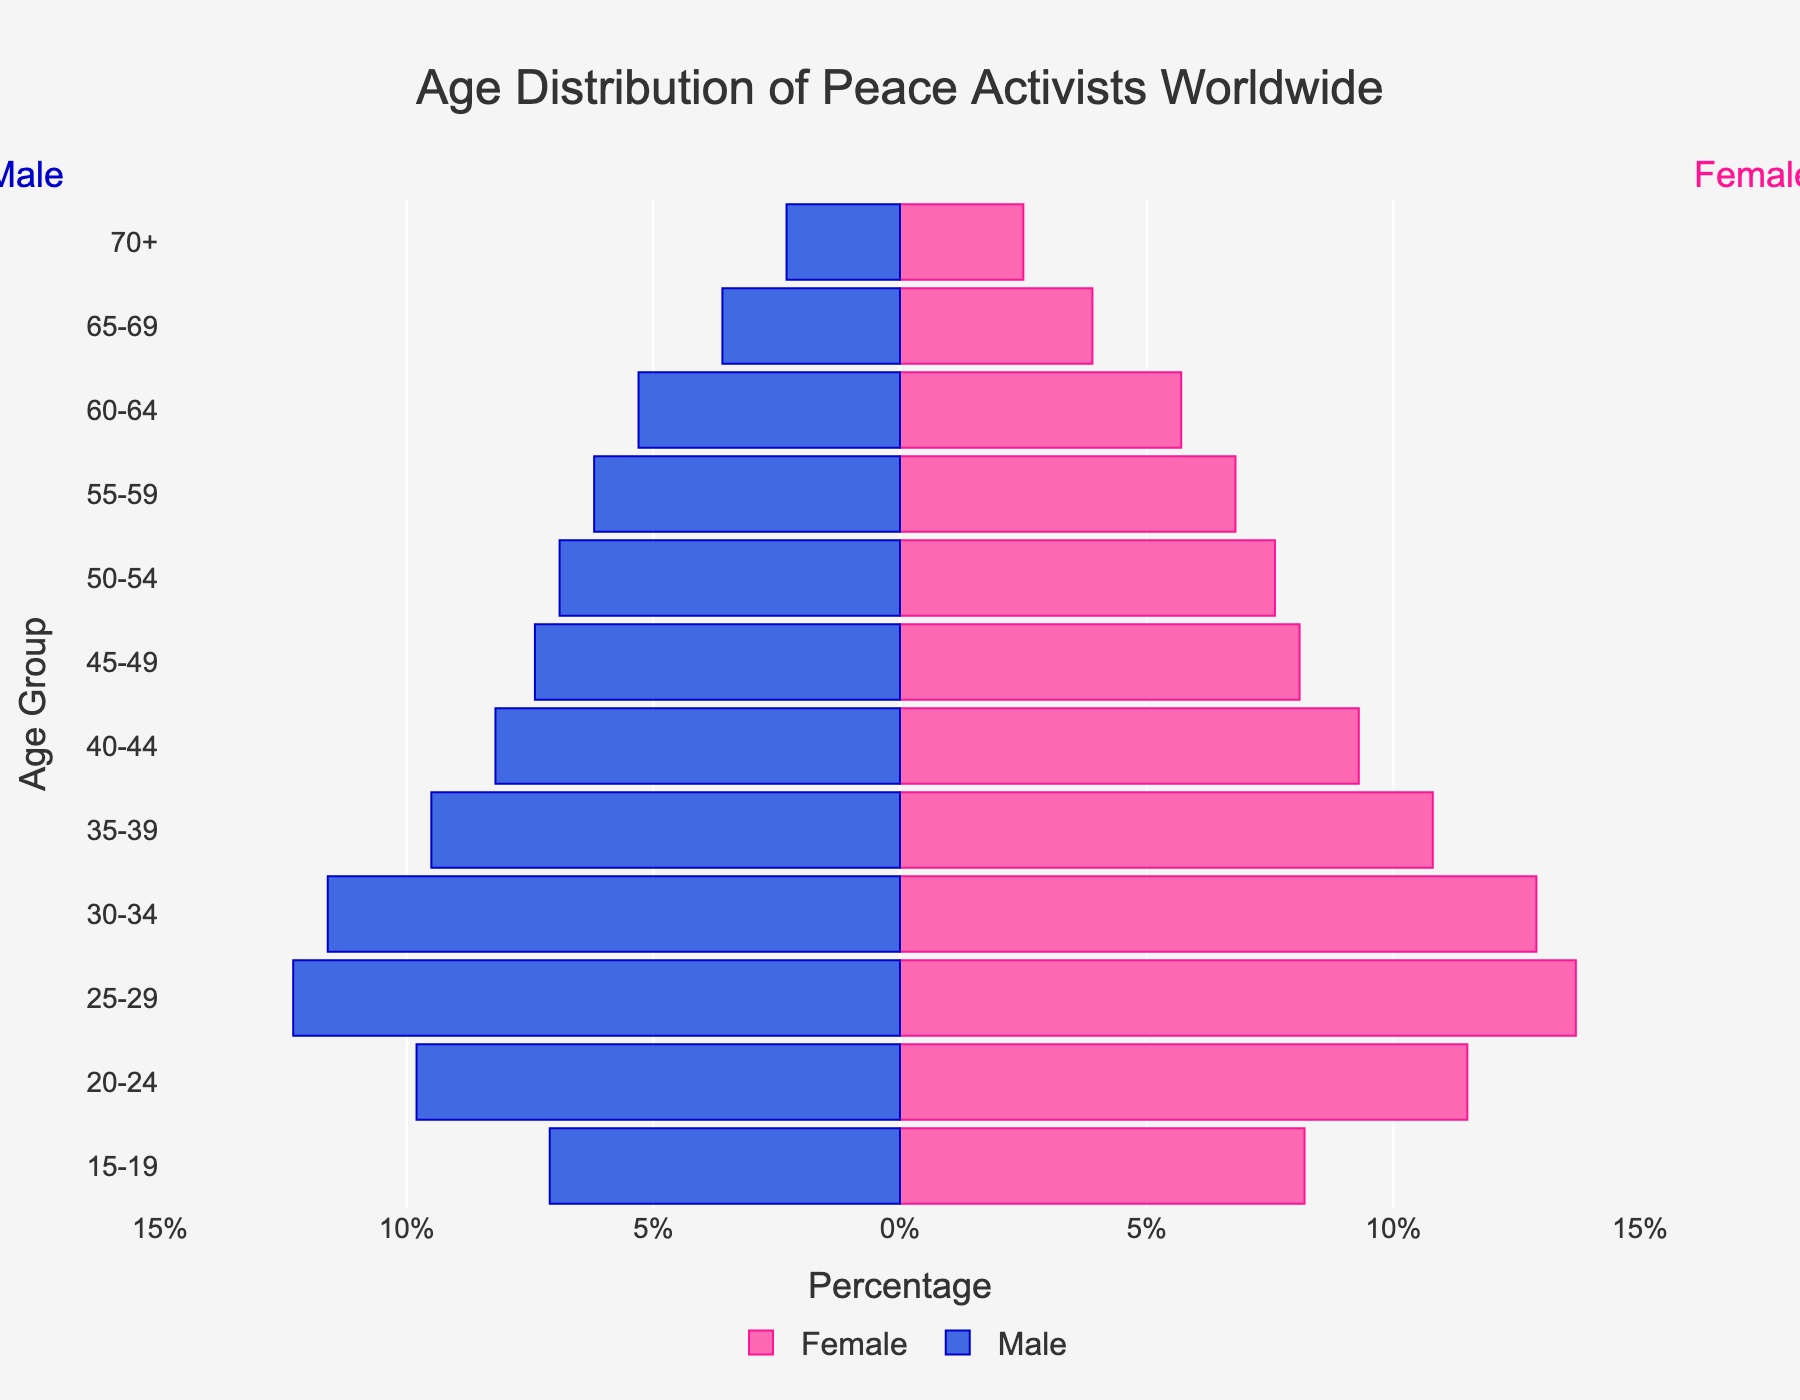What is the title of the figure? The title is typically shown at the top of the figure. In this case, it is "Age Distribution of Peace Activists Worldwide".
Answer: "Age Distribution of Peace Activists Worldwide" What are the units on the x-axis? The x-axis typically shows the units of measurement. Here, the percentage values are used with increments shown as "-15%", "-10%", "-5%", "0%", "5%", "10%", "15%".
Answer: Percentage Which age group has the highest percentage of female peace activists? The height of the bars represents the percentage. By observing the bars on the right side (female), the age group 25-29 has the highest percentage of 13.7%.
Answer: 25-29 Which age group has the highest percentage of male peace activists? By looking at the bars on the left side (male), the age group 25-29 also has the highest percentage at 12.3%.
Answer: 25-29 How do the percentages of male and female peace activists compare in the 20-24 age group? Look at the bars corresponding to the 20-24 age group. The percentage for females is 11.5%, and the percentage for males is 9.8%. Compare the two values by subtracting the percentage of males from that of females (11.5% - 9.8%).
Answer: Females higher by 1.7% What is the combined percentage of male and female peace activists aged 60-64? Add the percentages for both males and females in the 60-64 age group (5.7% for females, 5.3% for males).
Answer: 11% Which gender has fewer peace activists aged 70 and above? Compare the heights of the bars for the 70+ group. The male bar and female bar are 2.3% and 2.5% respectively. Hence, males have fewer activists in this group.
Answer: Male What is the overall trend in the distribution of peace activists as age increases? Observe the trend in bar heights from younger to older age groups for both genders. Both the female and male percentages decrease with increasing age.
Answer: Decreasing What percentage of peace activists are in the 40-44 age group for males and females combined? Add the percentages for both males and females in the 40-44 age group (9.3% for females, 8.2% for males).
Answer: 17.5% In the 30-34 age group, are male or female activists more numerous? Compare the heights of the bars for the 30-34 age group. The female bar is 12.9% and the male bar is 11.6%. Thus, there are more female activists.
Answer: Female 